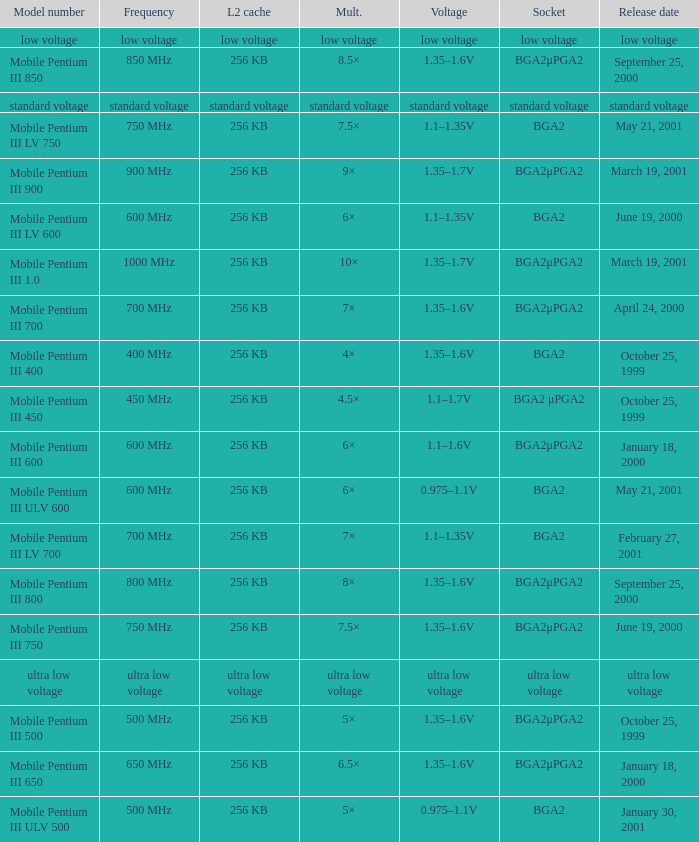Which model has a frequency of 750 mhz and a socket of bga2μpga2? Mobile Pentium III 750. 